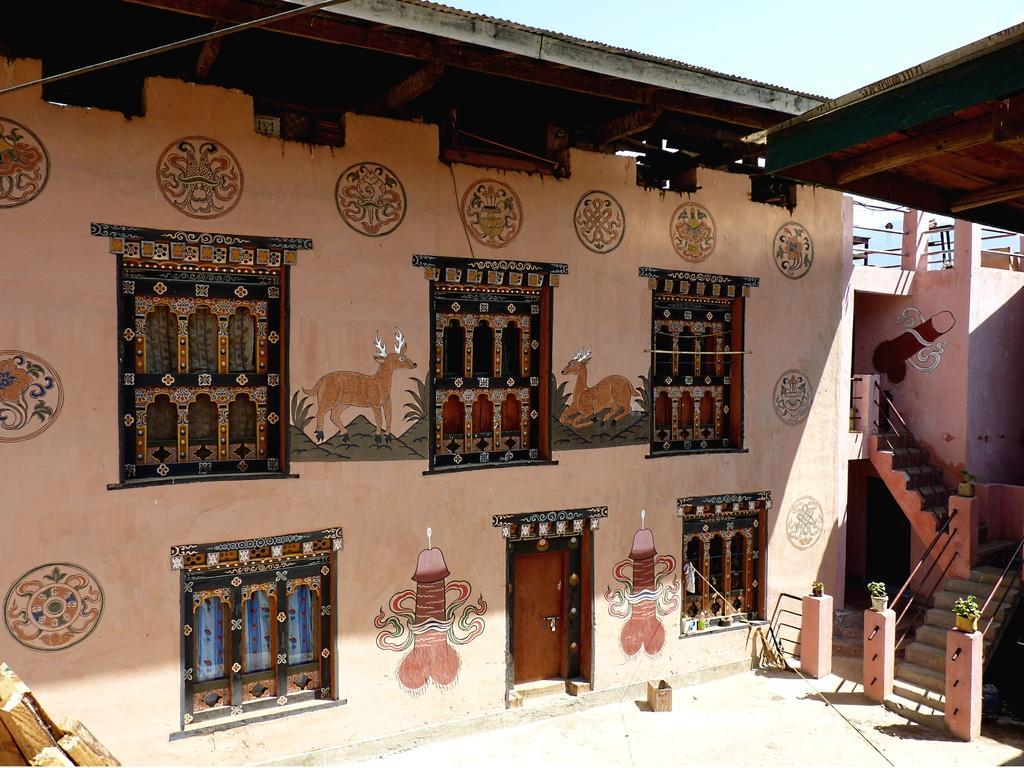Please provide a concise description of this image. This looks like a house with the windows and a door. I can see the wall painting. These are the stairs with the staircase holder. I can see the flower pots with the plants in it. This looks like a cardboard box. This is the roof. 